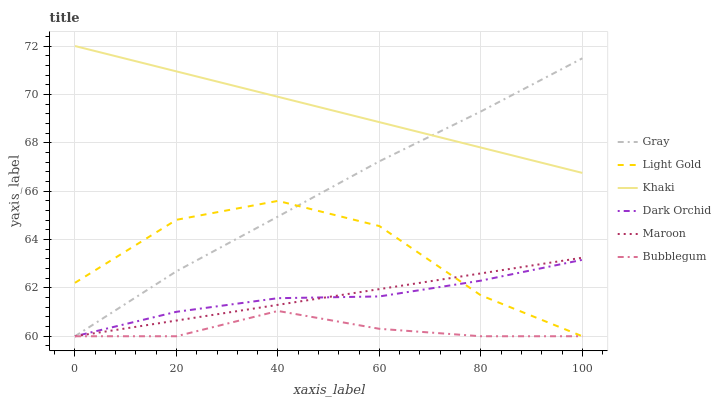Does Bubblegum have the minimum area under the curve?
Answer yes or no. Yes. Does Khaki have the maximum area under the curve?
Answer yes or no. Yes. Does Dark Orchid have the minimum area under the curve?
Answer yes or no. No. Does Dark Orchid have the maximum area under the curve?
Answer yes or no. No. Is Maroon the smoothest?
Answer yes or no. Yes. Is Light Gold the roughest?
Answer yes or no. Yes. Is Khaki the smoothest?
Answer yes or no. No. Is Khaki the roughest?
Answer yes or no. No. Does Gray have the lowest value?
Answer yes or no. Yes. Does Khaki have the lowest value?
Answer yes or no. No. Does Khaki have the highest value?
Answer yes or no. Yes. Does Dark Orchid have the highest value?
Answer yes or no. No. Is Maroon less than Khaki?
Answer yes or no. Yes. Is Khaki greater than Bubblegum?
Answer yes or no. Yes. Does Maroon intersect Dark Orchid?
Answer yes or no. Yes. Is Maroon less than Dark Orchid?
Answer yes or no. No. Is Maroon greater than Dark Orchid?
Answer yes or no. No. Does Maroon intersect Khaki?
Answer yes or no. No. 